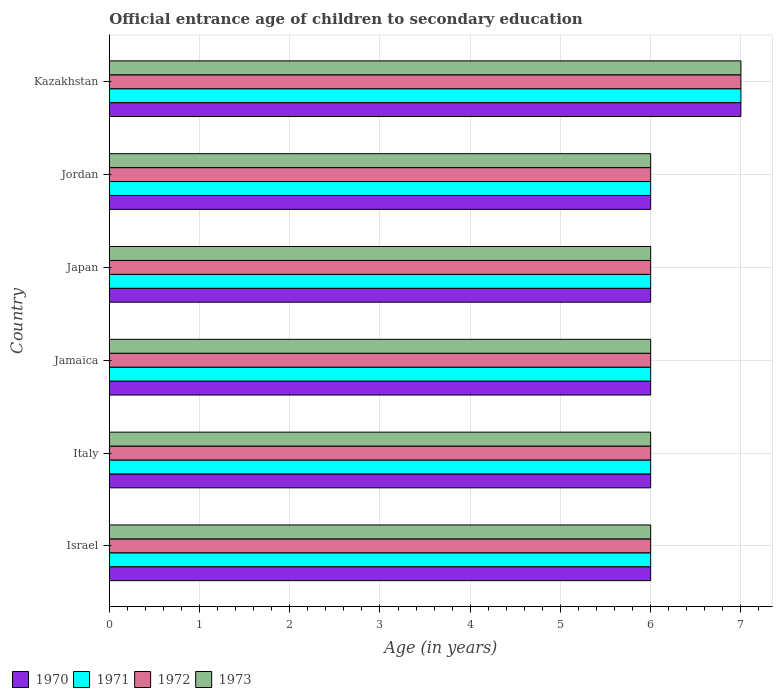Are the number of bars per tick equal to the number of legend labels?
Ensure brevity in your answer.  Yes. Are the number of bars on each tick of the Y-axis equal?
Provide a short and direct response. Yes. How many bars are there on the 6th tick from the top?
Keep it short and to the point. 4. How many bars are there on the 5th tick from the bottom?
Give a very brief answer. 4. In how many cases, is the number of bars for a given country not equal to the number of legend labels?
Provide a succinct answer. 0. Across all countries, what is the minimum secondary school starting age of children in 1972?
Provide a succinct answer. 6. In which country was the secondary school starting age of children in 1973 maximum?
Provide a short and direct response. Kazakhstan. In which country was the secondary school starting age of children in 1971 minimum?
Give a very brief answer. Israel. What is the difference between the secondary school starting age of children in 1972 in Israel and that in Japan?
Provide a short and direct response. 0. What is the average secondary school starting age of children in 1970 per country?
Your answer should be very brief. 6.17. What is the difference between the secondary school starting age of children in 1972 and secondary school starting age of children in 1973 in Israel?
Your answer should be compact. 0. In how many countries, is the secondary school starting age of children in 1971 greater than 4.6 years?
Provide a succinct answer. 6. Is the secondary school starting age of children in 1972 in Israel less than that in Kazakhstan?
Your response must be concise. Yes. Is the difference between the secondary school starting age of children in 1972 in Israel and Kazakhstan greater than the difference between the secondary school starting age of children in 1973 in Israel and Kazakhstan?
Provide a short and direct response. No. What is the difference between the highest and the lowest secondary school starting age of children in 1971?
Your answer should be compact. 1. In how many countries, is the secondary school starting age of children in 1971 greater than the average secondary school starting age of children in 1971 taken over all countries?
Provide a short and direct response. 1. Is the sum of the secondary school starting age of children in 1970 in Israel and Italy greater than the maximum secondary school starting age of children in 1972 across all countries?
Your answer should be compact. Yes. Is it the case that in every country, the sum of the secondary school starting age of children in 1970 and secondary school starting age of children in 1971 is greater than the sum of secondary school starting age of children in 1972 and secondary school starting age of children in 1973?
Provide a succinct answer. No. What does the 4th bar from the top in Kazakhstan represents?
Provide a short and direct response. 1970. What does the 1st bar from the bottom in Jamaica represents?
Make the answer very short. 1970. Is it the case that in every country, the sum of the secondary school starting age of children in 1971 and secondary school starting age of children in 1973 is greater than the secondary school starting age of children in 1970?
Make the answer very short. Yes. Are all the bars in the graph horizontal?
Ensure brevity in your answer.  Yes. How many countries are there in the graph?
Offer a terse response. 6. Are the values on the major ticks of X-axis written in scientific E-notation?
Give a very brief answer. No. Does the graph contain any zero values?
Offer a very short reply. No. Does the graph contain grids?
Your answer should be compact. Yes. How many legend labels are there?
Your answer should be compact. 4. How are the legend labels stacked?
Give a very brief answer. Horizontal. What is the title of the graph?
Provide a short and direct response. Official entrance age of children to secondary education. Does "1997" appear as one of the legend labels in the graph?
Offer a terse response. No. What is the label or title of the X-axis?
Keep it short and to the point. Age (in years). What is the Age (in years) of 1973 in Israel?
Your answer should be compact. 6. What is the Age (in years) in 1973 in Italy?
Your answer should be compact. 6. What is the Age (in years) of 1972 in Jamaica?
Ensure brevity in your answer.  6. What is the Age (in years) of 1973 in Jamaica?
Keep it short and to the point. 6. What is the Age (in years) in 1970 in Japan?
Offer a very short reply. 6. What is the Age (in years) in 1972 in Jordan?
Offer a very short reply. 6. What is the Age (in years) in 1971 in Kazakhstan?
Keep it short and to the point. 7. What is the Age (in years) of 1972 in Kazakhstan?
Your answer should be very brief. 7. What is the Age (in years) in 1973 in Kazakhstan?
Your response must be concise. 7. Across all countries, what is the maximum Age (in years) of 1970?
Your answer should be compact. 7. Across all countries, what is the maximum Age (in years) in 1971?
Offer a terse response. 7. Across all countries, what is the maximum Age (in years) in 1973?
Your answer should be very brief. 7. Across all countries, what is the minimum Age (in years) in 1971?
Keep it short and to the point. 6. What is the total Age (in years) of 1970 in the graph?
Your answer should be compact. 37. What is the total Age (in years) of 1971 in the graph?
Ensure brevity in your answer.  37. What is the difference between the Age (in years) in 1970 in Israel and that in Italy?
Ensure brevity in your answer.  0. What is the difference between the Age (in years) in 1973 in Israel and that in Italy?
Give a very brief answer. 0. What is the difference between the Age (in years) of 1970 in Israel and that in Jamaica?
Make the answer very short. 0. What is the difference between the Age (in years) in 1972 in Israel and that in Jamaica?
Your answer should be very brief. 0. What is the difference between the Age (in years) of 1973 in Israel and that in Jamaica?
Keep it short and to the point. 0. What is the difference between the Age (in years) in 1970 in Israel and that in Japan?
Your answer should be compact. 0. What is the difference between the Age (in years) of 1972 in Israel and that in Japan?
Provide a short and direct response. 0. What is the difference between the Age (in years) in 1971 in Israel and that in Jordan?
Keep it short and to the point. 0. What is the difference between the Age (in years) of 1972 in Israel and that in Jordan?
Provide a succinct answer. 0. What is the difference between the Age (in years) in 1973 in Israel and that in Jordan?
Provide a succinct answer. 0. What is the difference between the Age (in years) in 1972 in Israel and that in Kazakhstan?
Give a very brief answer. -1. What is the difference between the Age (in years) in 1972 in Italy and that in Jamaica?
Your answer should be very brief. 0. What is the difference between the Age (in years) of 1973 in Italy and that in Japan?
Make the answer very short. 0. What is the difference between the Age (in years) of 1970 in Italy and that in Jordan?
Offer a very short reply. 0. What is the difference between the Age (in years) in 1971 in Italy and that in Jordan?
Ensure brevity in your answer.  0. What is the difference between the Age (in years) in 1972 in Italy and that in Jordan?
Provide a succinct answer. 0. What is the difference between the Age (in years) of 1973 in Italy and that in Jordan?
Keep it short and to the point. 0. What is the difference between the Age (in years) of 1970 in Italy and that in Kazakhstan?
Give a very brief answer. -1. What is the difference between the Age (in years) in 1971 in Italy and that in Kazakhstan?
Offer a terse response. -1. What is the difference between the Age (in years) in 1972 in Italy and that in Kazakhstan?
Keep it short and to the point. -1. What is the difference between the Age (in years) of 1970 in Jamaica and that in Japan?
Your answer should be very brief. 0. What is the difference between the Age (in years) of 1971 in Jamaica and that in Japan?
Keep it short and to the point. 0. What is the difference between the Age (in years) in 1973 in Jamaica and that in Japan?
Provide a succinct answer. 0. What is the difference between the Age (in years) in 1971 in Jamaica and that in Jordan?
Your response must be concise. 0. What is the difference between the Age (in years) in 1970 in Jamaica and that in Kazakhstan?
Give a very brief answer. -1. What is the difference between the Age (in years) of 1971 in Jamaica and that in Kazakhstan?
Provide a short and direct response. -1. What is the difference between the Age (in years) in 1972 in Jamaica and that in Kazakhstan?
Provide a short and direct response. -1. What is the difference between the Age (in years) in 1971 in Japan and that in Jordan?
Your answer should be very brief. 0. What is the difference between the Age (in years) in 1972 in Japan and that in Jordan?
Keep it short and to the point. 0. What is the difference between the Age (in years) of 1973 in Japan and that in Jordan?
Provide a succinct answer. 0. What is the difference between the Age (in years) of 1973 in Japan and that in Kazakhstan?
Your answer should be very brief. -1. What is the difference between the Age (in years) of 1973 in Jordan and that in Kazakhstan?
Make the answer very short. -1. What is the difference between the Age (in years) in 1970 in Israel and the Age (in years) in 1972 in Italy?
Keep it short and to the point. 0. What is the difference between the Age (in years) of 1970 in Israel and the Age (in years) of 1973 in Italy?
Make the answer very short. 0. What is the difference between the Age (in years) of 1971 in Israel and the Age (in years) of 1973 in Italy?
Ensure brevity in your answer.  0. What is the difference between the Age (in years) of 1970 in Israel and the Age (in years) of 1971 in Japan?
Ensure brevity in your answer.  0. What is the difference between the Age (in years) in 1971 in Israel and the Age (in years) in 1973 in Japan?
Provide a short and direct response. 0. What is the difference between the Age (in years) of 1970 in Israel and the Age (in years) of 1971 in Jordan?
Make the answer very short. 0. What is the difference between the Age (in years) in 1970 in Israel and the Age (in years) in 1972 in Jordan?
Your answer should be compact. 0. What is the difference between the Age (in years) in 1971 in Israel and the Age (in years) in 1973 in Jordan?
Provide a short and direct response. 0. What is the difference between the Age (in years) of 1970 in Israel and the Age (in years) of 1972 in Kazakhstan?
Offer a terse response. -1. What is the difference between the Age (in years) in 1970 in Italy and the Age (in years) in 1973 in Jamaica?
Ensure brevity in your answer.  0. What is the difference between the Age (in years) in 1971 in Italy and the Age (in years) in 1972 in Jamaica?
Offer a very short reply. 0. What is the difference between the Age (in years) of 1971 in Italy and the Age (in years) of 1973 in Jamaica?
Provide a short and direct response. 0. What is the difference between the Age (in years) of 1972 in Italy and the Age (in years) of 1973 in Jamaica?
Your answer should be compact. 0. What is the difference between the Age (in years) in 1970 in Italy and the Age (in years) in 1973 in Japan?
Your answer should be very brief. 0. What is the difference between the Age (in years) of 1971 in Italy and the Age (in years) of 1972 in Japan?
Keep it short and to the point. 0. What is the difference between the Age (in years) in 1971 in Italy and the Age (in years) in 1973 in Japan?
Offer a terse response. 0. What is the difference between the Age (in years) in 1970 in Italy and the Age (in years) in 1971 in Jordan?
Keep it short and to the point. 0. What is the difference between the Age (in years) of 1970 in Italy and the Age (in years) of 1973 in Jordan?
Ensure brevity in your answer.  0. What is the difference between the Age (in years) in 1970 in Italy and the Age (in years) in 1972 in Kazakhstan?
Ensure brevity in your answer.  -1. What is the difference between the Age (in years) in 1971 in Italy and the Age (in years) in 1973 in Kazakhstan?
Your answer should be compact. -1. What is the difference between the Age (in years) in 1970 in Jamaica and the Age (in years) in 1971 in Japan?
Give a very brief answer. 0. What is the difference between the Age (in years) in 1971 in Jamaica and the Age (in years) in 1973 in Japan?
Ensure brevity in your answer.  0. What is the difference between the Age (in years) of 1970 in Jamaica and the Age (in years) of 1971 in Jordan?
Make the answer very short. 0. What is the difference between the Age (in years) of 1971 in Jamaica and the Age (in years) of 1973 in Jordan?
Offer a very short reply. 0. What is the difference between the Age (in years) of 1972 in Jamaica and the Age (in years) of 1973 in Jordan?
Ensure brevity in your answer.  0. What is the difference between the Age (in years) in 1970 in Jamaica and the Age (in years) in 1972 in Kazakhstan?
Provide a succinct answer. -1. What is the difference between the Age (in years) in 1971 in Jamaica and the Age (in years) in 1972 in Kazakhstan?
Provide a succinct answer. -1. What is the difference between the Age (in years) in 1972 in Jamaica and the Age (in years) in 1973 in Kazakhstan?
Your response must be concise. -1. What is the difference between the Age (in years) in 1971 in Japan and the Age (in years) in 1972 in Jordan?
Keep it short and to the point. 0. What is the difference between the Age (in years) in 1971 in Japan and the Age (in years) in 1973 in Jordan?
Your answer should be compact. 0. What is the difference between the Age (in years) in 1970 in Japan and the Age (in years) in 1971 in Kazakhstan?
Offer a very short reply. -1. What is the difference between the Age (in years) of 1970 in Japan and the Age (in years) of 1972 in Kazakhstan?
Make the answer very short. -1. What is the difference between the Age (in years) of 1970 in Japan and the Age (in years) of 1973 in Kazakhstan?
Give a very brief answer. -1. What is the difference between the Age (in years) of 1972 in Japan and the Age (in years) of 1973 in Kazakhstan?
Make the answer very short. -1. What is the difference between the Age (in years) in 1970 in Jordan and the Age (in years) in 1971 in Kazakhstan?
Offer a very short reply. -1. What is the difference between the Age (in years) of 1970 in Jordan and the Age (in years) of 1973 in Kazakhstan?
Provide a short and direct response. -1. What is the average Age (in years) of 1970 per country?
Your answer should be compact. 6.17. What is the average Age (in years) in 1971 per country?
Your answer should be very brief. 6.17. What is the average Age (in years) in 1972 per country?
Make the answer very short. 6.17. What is the average Age (in years) in 1973 per country?
Your answer should be compact. 6.17. What is the difference between the Age (in years) of 1970 and Age (in years) of 1971 in Israel?
Your answer should be very brief. 0. What is the difference between the Age (in years) in 1970 and Age (in years) in 1973 in Israel?
Offer a very short reply. 0. What is the difference between the Age (in years) of 1971 and Age (in years) of 1972 in Israel?
Ensure brevity in your answer.  0. What is the difference between the Age (in years) of 1971 and Age (in years) of 1973 in Israel?
Keep it short and to the point. 0. What is the difference between the Age (in years) in 1970 and Age (in years) in 1972 in Italy?
Your response must be concise. 0. What is the difference between the Age (in years) in 1970 and Age (in years) in 1973 in Italy?
Ensure brevity in your answer.  0. What is the difference between the Age (in years) of 1970 and Age (in years) of 1971 in Jamaica?
Your response must be concise. 0. What is the difference between the Age (in years) in 1970 and Age (in years) in 1972 in Jamaica?
Your response must be concise. 0. What is the difference between the Age (in years) in 1970 and Age (in years) in 1973 in Jamaica?
Your answer should be very brief. 0. What is the difference between the Age (in years) in 1971 and Age (in years) in 1972 in Jamaica?
Give a very brief answer. 0. What is the difference between the Age (in years) of 1972 and Age (in years) of 1973 in Jamaica?
Your answer should be very brief. 0. What is the difference between the Age (in years) of 1970 and Age (in years) of 1971 in Japan?
Make the answer very short. 0. What is the difference between the Age (in years) of 1971 and Age (in years) of 1973 in Japan?
Your response must be concise. 0. What is the difference between the Age (in years) in 1972 and Age (in years) in 1973 in Japan?
Make the answer very short. 0. What is the difference between the Age (in years) in 1970 and Age (in years) in 1972 in Jordan?
Provide a succinct answer. 0. What is the difference between the Age (in years) in 1970 and Age (in years) in 1971 in Kazakhstan?
Provide a short and direct response. 0. What is the difference between the Age (in years) of 1970 and Age (in years) of 1972 in Kazakhstan?
Provide a succinct answer. 0. What is the difference between the Age (in years) in 1970 and Age (in years) in 1973 in Kazakhstan?
Make the answer very short. 0. What is the difference between the Age (in years) in 1972 and Age (in years) in 1973 in Kazakhstan?
Make the answer very short. 0. What is the ratio of the Age (in years) in 1972 in Israel to that in Italy?
Offer a very short reply. 1. What is the ratio of the Age (in years) in 1970 in Israel to that in Jamaica?
Give a very brief answer. 1. What is the ratio of the Age (in years) in 1973 in Israel to that in Jamaica?
Give a very brief answer. 1. What is the ratio of the Age (in years) of 1970 in Israel to that in Japan?
Provide a short and direct response. 1. What is the ratio of the Age (in years) of 1971 in Israel to that in Japan?
Give a very brief answer. 1. What is the ratio of the Age (in years) of 1973 in Israel to that in Japan?
Make the answer very short. 1. What is the ratio of the Age (in years) in 1970 in Israel to that in Jordan?
Your answer should be very brief. 1. What is the ratio of the Age (in years) of 1971 in Israel to that in Jordan?
Offer a very short reply. 1. What is the ratio of the Age (in years) of 1973 in Israel to that in Jordan?
Make the answer very short. 1. What is the ratio of the Age (in years) in 1971 in Israel to that in Kazakhstan?
Your answer should be very brief. 0.86. What is the ratio of the Age (in years) in 1970 in Italy to that in Jordan?
Offer a terse response. 1. What is the ratio of the Age (in years) of 1973 in Italy to that in Jordan?
Offer a very short reply. 1. What is the ratio of the Age (in years) in 1971 in Italy to that in Kazakhstan?
Provide a short and direct response. 0.86. What is the ratio of the Age (in years) of 1972 in Italy to that in Kazakhstan?
Ensure brevity in your answer.  0.86. What is the ratio of the Age (in years) of 1970 in Jamaica to that in Japan?
Offer a very short reply. 1. What is the ratio of the Age (in years) of 1972 in Jamaica to that in Japan?
Your answer should be compact. 1. What is the ratio of the Age (in years) of 1973 in Jamaica to that in Japan?
Ensure brevity in your answer.  1. What is the ratio of the Age (in years) in 1973 in Jamaica to that in Jordan?
Offer a very short reply. 1. What is the ratio of the Age (in years) in 1971 in Jamaica to that in Kazakhstan?
Provide a short and direct response. 0.86. What is the ratio of the Age (in years) of 1972 in Jamaica to that in Kazakhstan?
Keep it short and to the point. 0.86. What is the ratio of the Age (in years) of 1973 in Jamaica to that in Kazakhstan?
Provide a succinct answer. 0.86. What is the ratio of the Age (in years) of 1971 in Japan to that in Kazakhstan?
Your response must be concise. 0.86. What is the ratio of the Age (in years) in 1972 in Japan to that in Kazakhstan?
Your answer should be compact. 0.86. What is the ratio of the Age (in years) of 1971 in Jordan to that in Kazakhstan?
Your answer should be very brief. 0.86. What is the ratio of the Age (in years) of 1972 in Jordan to that in Kazakhstan?
Your answer should be compact. 0.86. What is the ratio of the Age (in years) of 1973 in Jordan to that in Kazakhstan?
Your answer should be very brief. 0.86. What is the difference between the highest and the second highest Age (in years) in 1970?
Keep it short and to the point. 1. What is the difference between the highest and the second highest Age (in years) of 1971?
Your response must be concise. 1. What is the difference between the highest and the second highest Age (in years) of 1972?
Offer a very short reply. 1. What is the difference between the highest and the lowest Age (in years) in 1970?
Ensure brevity in your answer.  1. What is the difference between the highest and the lowest Age (in years) in 1972?
Your answer should be compact. 1. What is the difference between the highest and the lowest Age (in years) of 1973?
Offer a terse response. 1. 